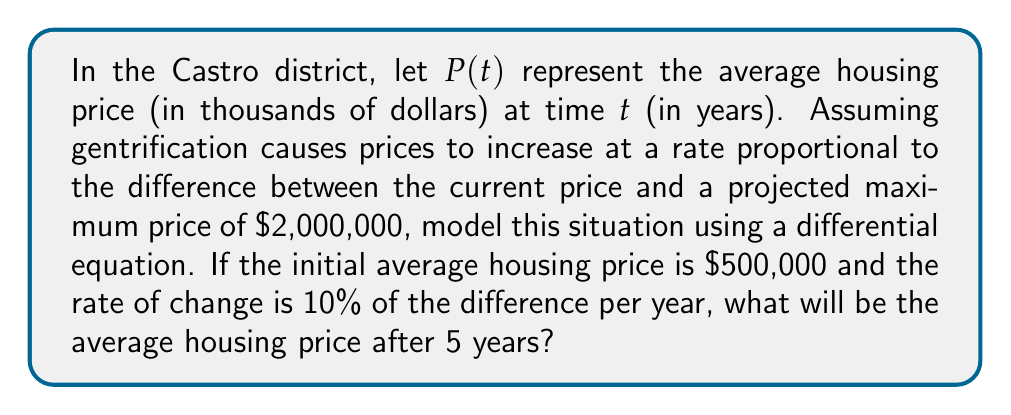Can you answer this question? 1) We can model this situation using the logistic differential equation:

   $$\frac{dP}{dt} = k(M - P)$$

   where $k$ is the rate constant, and $M$ is the maximum price.

2) Given information:
   - Initial price $P(0) = 500$ (in thousands)
   - Maximum price $M = 2000$ (in thousands)
   - Rate of change is 10% of the difference per year, so $k = 0.1$

3) Our differential equation becomes:

   $$\frac{dP}{dt} = 0.1(2000 - P)$$

4) The solution to this differential equation is:

   $$P(t) = M - (M - P(0))e^{-kt}$$

5) Substituting our values:

   $$P(t) = 2000 - (2000 - 500)e^{-0.1t}$$
   $$P(t) = 2000 - 1500e^{-0.1t}$$

6) To find the price after 5 years, we calculate $P(5)$:

   $$P(5) = 2000 - 1500e^{-0.1(5)}$$
   $$P(5) = 2000 - 1500e^{-0.5}$$
   $$P(5) = 2000 - 1500(0.6065)$$
   $$P(5) = 2000 - 909.75$$
   $$P(5) = 1090.25$$

7) Therefore, after 5 years, the average housing price will be $1,090,250.
Answer: $1,090,250 